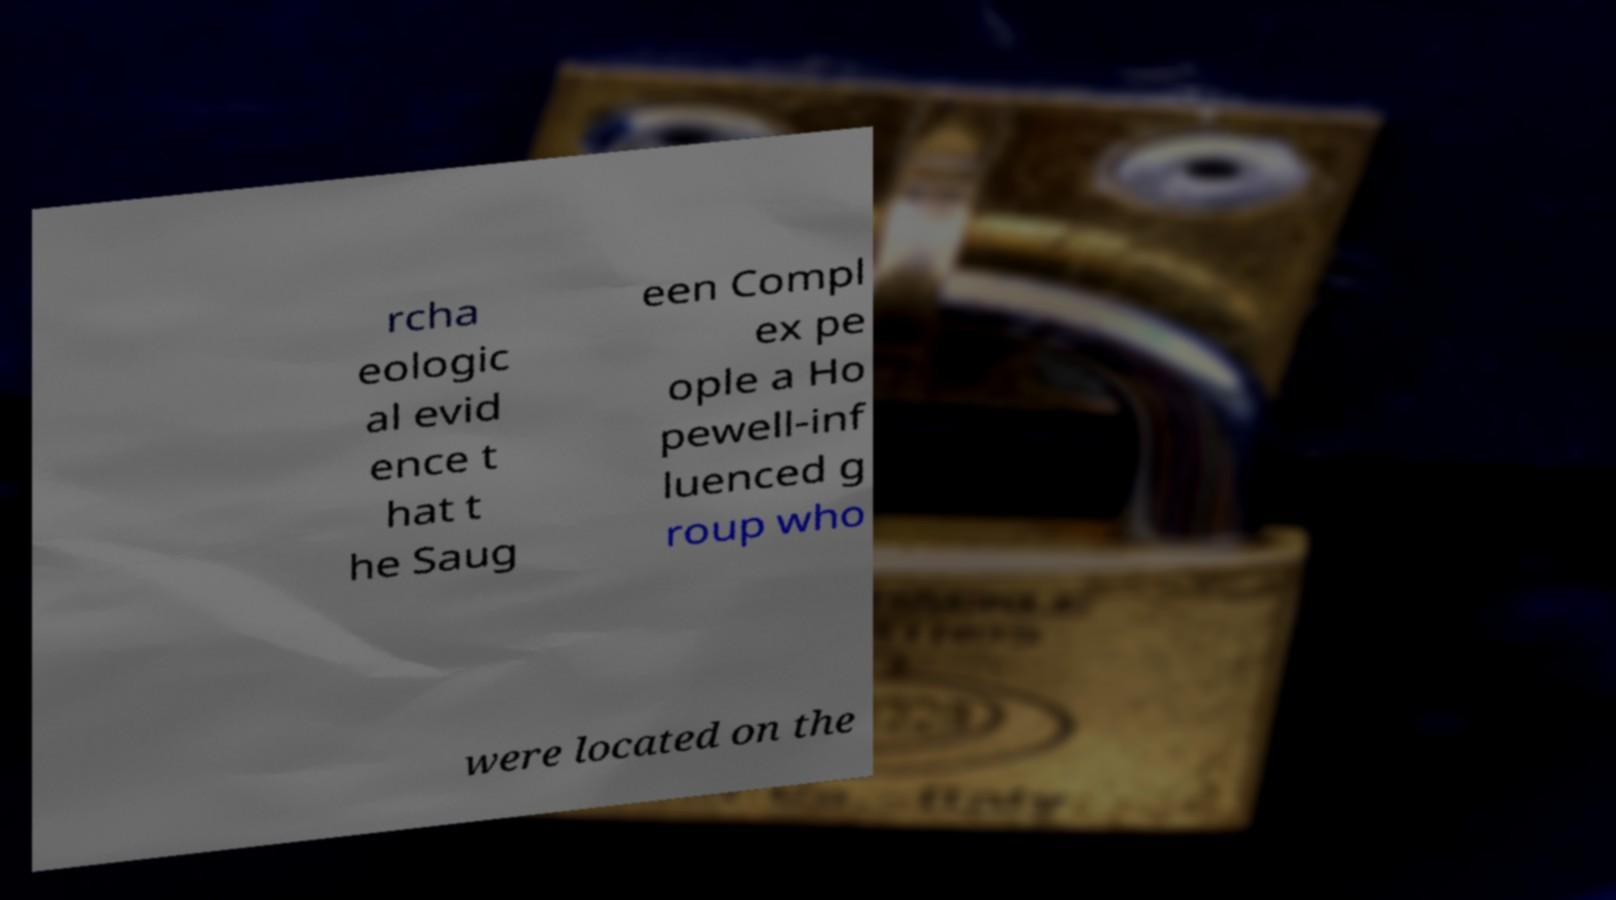What messages or text are displayed in this image? I need them in a readable, typed format. rcha eologic al evid ence t hat t he Saug een Compl ex pe ople a Ho pewell-inf luenced g roup who were located on the 